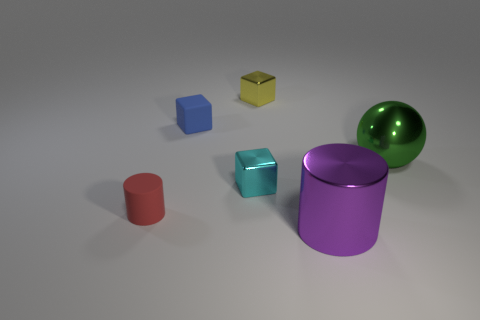What size is the shiny object that is both in front of the big green metal object and on the left side of the big purple cylinder?
Provide a short and direct response. Small. What number of other objects are the same size as the green thing?
Your answer should be very brief. 1. What color is the big metallic thing that is behind the purple cylinder in front of the small metallic object in front of the tiny yellow cube?
Offer a very short reply. Green. The metallic object that is right of the yellow object and behind the red cylinder has what shape?
Offer a terse response. Sphere. How many other things are the same shape as the cyan shiny thing?
Your response must be concise. 2. What is the shape of the small rubber thing that is in front of the big shiny object on the right side of the large shiny object in front of the tiny matte cylinder?
Offer a very short reply. Cylinder. How many things are either small purple matte cylinders or metallic cubes in front of the tiny blue thing?
Give a very brief answer. 1. Does the tiny shiny thing right of the cyan object have the same shape as the tiny metal thing in front of the yellow object?
Keep it short and to the point. Yes. How many objects are either tiny red objects or large things?
Keep it short and to the point. 3. Are there any tiny gray matte blocks?
Provide a short and direct response. No. 